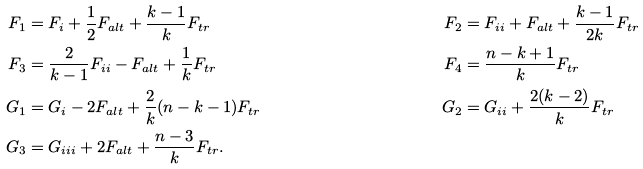Convert formula to latex. <formula><loc_0><loc_0><loc_500><loc_500>F _ { 1 } & = F _ { i } + \frac { 1 } { 2 } F _ { a l t } + \frac { k - 1 } { k } F _ { t r } & F _ { 2 } & = F _ { i i } + F _ { a l t } + \frac { k - 1 } { 2 k } F _ { t r } \\ F _ { 3 } & = \frac { 2 } { k - 1 } F _ { i i } - F _ { a l t } + \frac { 1 } { k } F _ { t r } & F _ { 4 } & = \frac { n - k + 1 } { k } F _ { t r } \\ G _ { 1 } & = G _ { i } - 2 F _ { a l t } + \frac { 2 } { k } ( n - k - 1 ) F _ { t r } & G _ { 2 } & = G _ { i i } + \frac { 2 ( k - 2 ) } { k } F _ { t r } \\ G _ { 3 } & = G _ { i i i } + 2 F _ { a l t } + \frac { n - 3 } { k } F _ { t r } .</formula> 